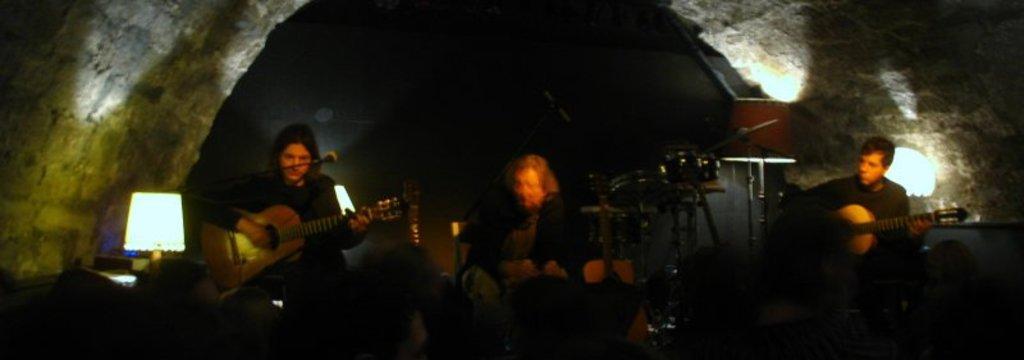Could you give a brief overview of what you see in this image? In this image I can see three people are playing guitar in front of a microphone. I can also see that few lamps and a wall. 